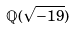<formula> <loc_0><loc_0><loc_500><loc_500>\mathbb { Q } ( \sqrt { - 1 9 } )</formula> 